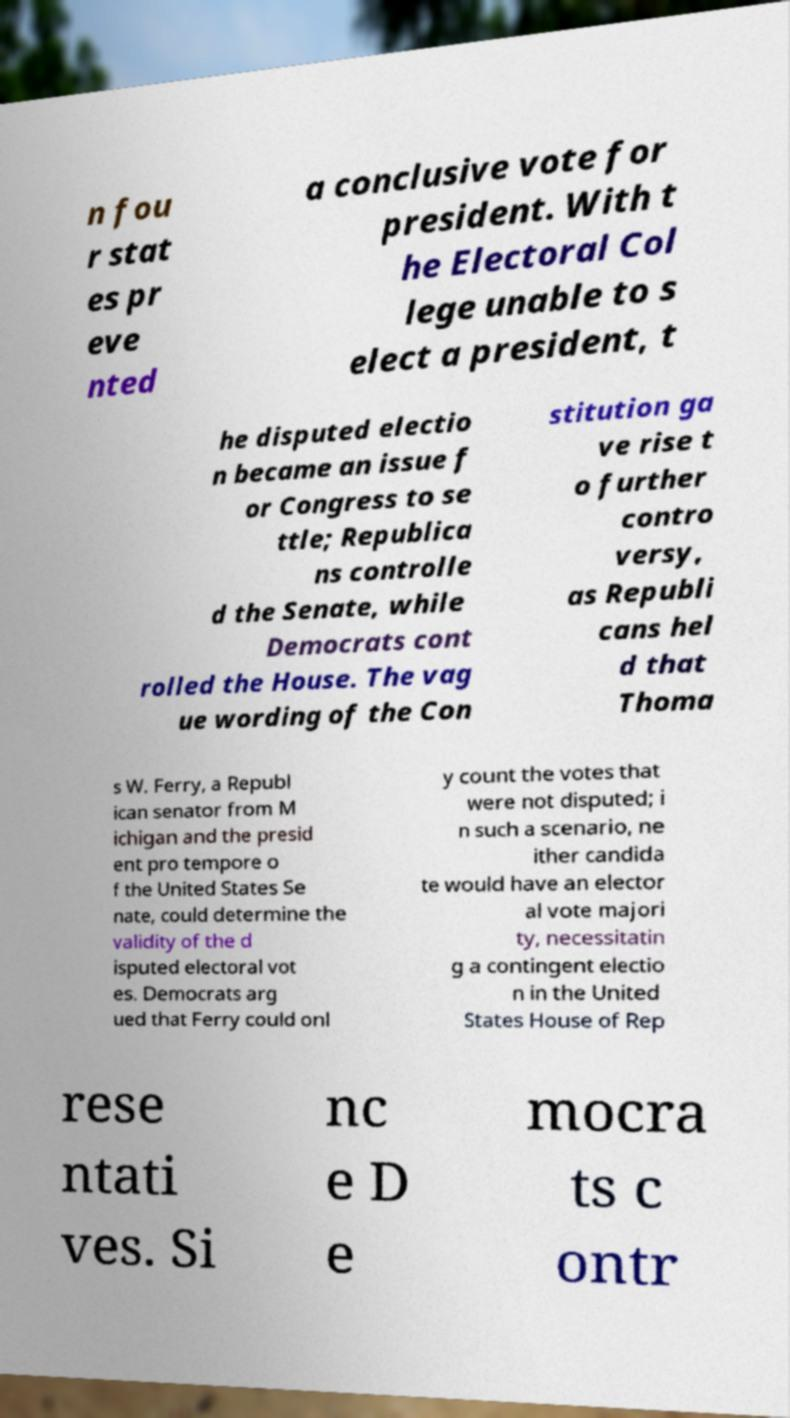Please identify and transcribe the text found in this image. n fou r stat es pr eve nted a conclusive vote for president. With t he Electoral Col lege unable to s elect a president, t he disputed electio n became an issue f or Congress to se ttle; Republica ns controlle d the Senate, while Democrats cont rolled the House. The vag ue wording of the Con stitution ga ve rise t o further contro versy, as Republi cans hel d that Thoma s W. Ferry, a Republ ican senator from M ichigan and the presid ent pro tempore o f the United States Se nate, could determine the validity of the d isputed electoral vot es. Democrats arg ued that Ferry could onl y count the votes that were not disputed; i n such a scenario, ne ither candida te would have an elector al vote majori ty, necessitatin g a contingent electio n in the United States House of Rep rese ntati ves. Si nc e D e mocra ts c ontr 